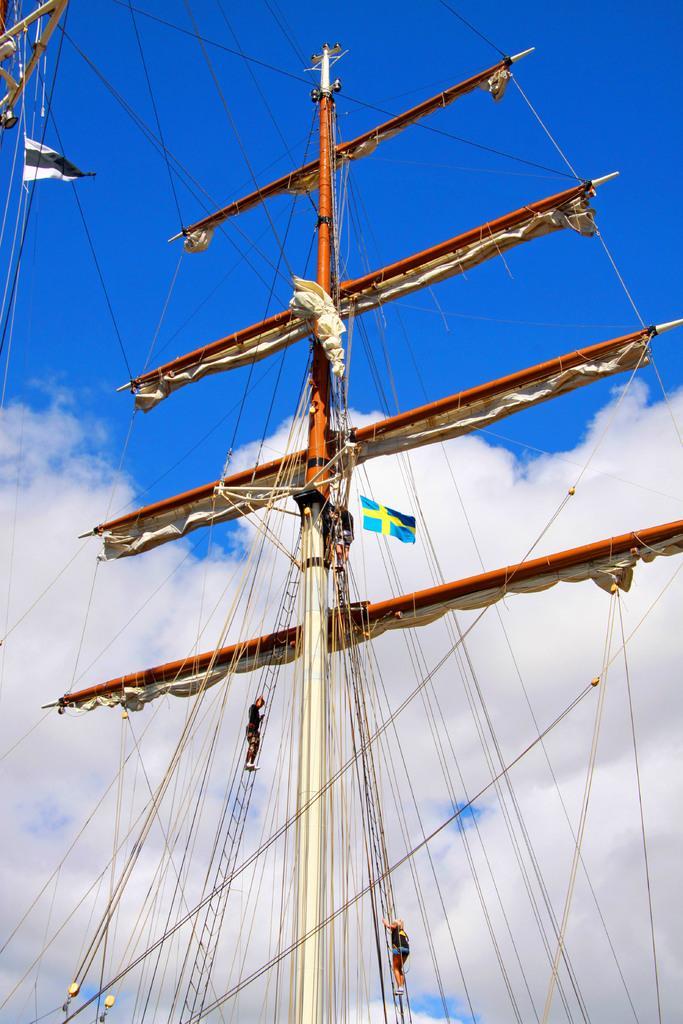In one or two sentences, can you explain what this image depicts? In this image I can see ship pole. We can see two person climbing. I can see flag,cloth and wires. The sky is in blue and white color. 